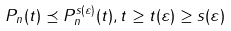<formula> <loc_0><loc_0><loc_500><loc_500>P _ { n } ( t ) \preceq P _ { n } ^ { s ( \varepsilon ) } ( t ) , t \geq t ( \varepsilon ) \geq s ( \varepsilon )</formula> 